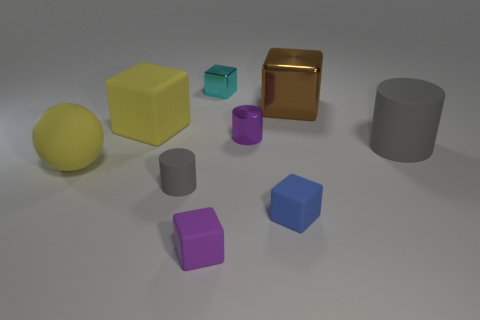Does the brown object have the same shape as the small blue matte thing?
Offer a very short reply. Yes. What size is the brown thing that is the same shape as the tiny blue object?
Provide a short and direct response. Large. How many tiny cylinders have the same material as the small cyan block?
Provide a short and direct response. 1. How many things are tiny gray rubber balls or rubber spheres?
Keep it short and to the point. 1. Are there any brown objects that are on the left side of the small purple thing that is behind the big ball?
Your answer should be compact. No. Are there more tiny purple objects that are behind the small metallic cube than large gray matte cylinders that are on the left side of the yellow ball?
Provide a short and direct response. No. There is a large block that is the same color as the large matte ball; what is it made of?
Provide a short and direct response. Rubber. How many tiny cylinders have the same color as the big matte block?
Offer a very short reply. 0. Is the color of the rubber cylinder that is behind the yellow ball the same as the big object on the left side of the yellow matte cube?
Provide a succinct answer. No. There is a blue cube; are there any small blue rubber things in front of it?
Offer a terse response. No. 